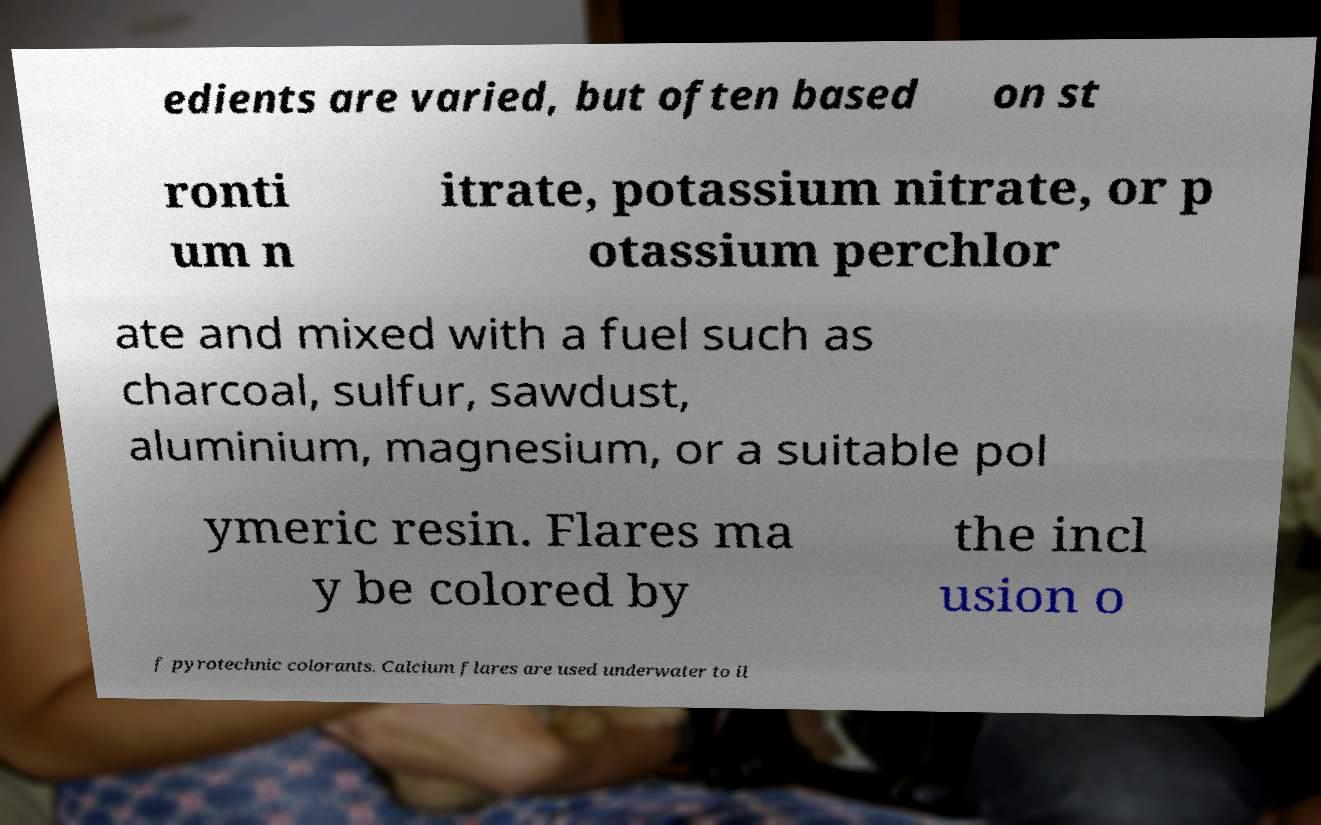Please read and relay the text visible in this image. What does it say? edients are varied, but often based on st ronti um n itrate, potassium nitrate, or p otassium perchlor ate and mixed with a fuel such as charcoal, sulfur, sawdust, aluminium, magnesium, or a suitable pol ymeric resin. Flares ma y be colored by the incl usion o f pyrotechnic colorants. Calcium flares are used underwater to il 